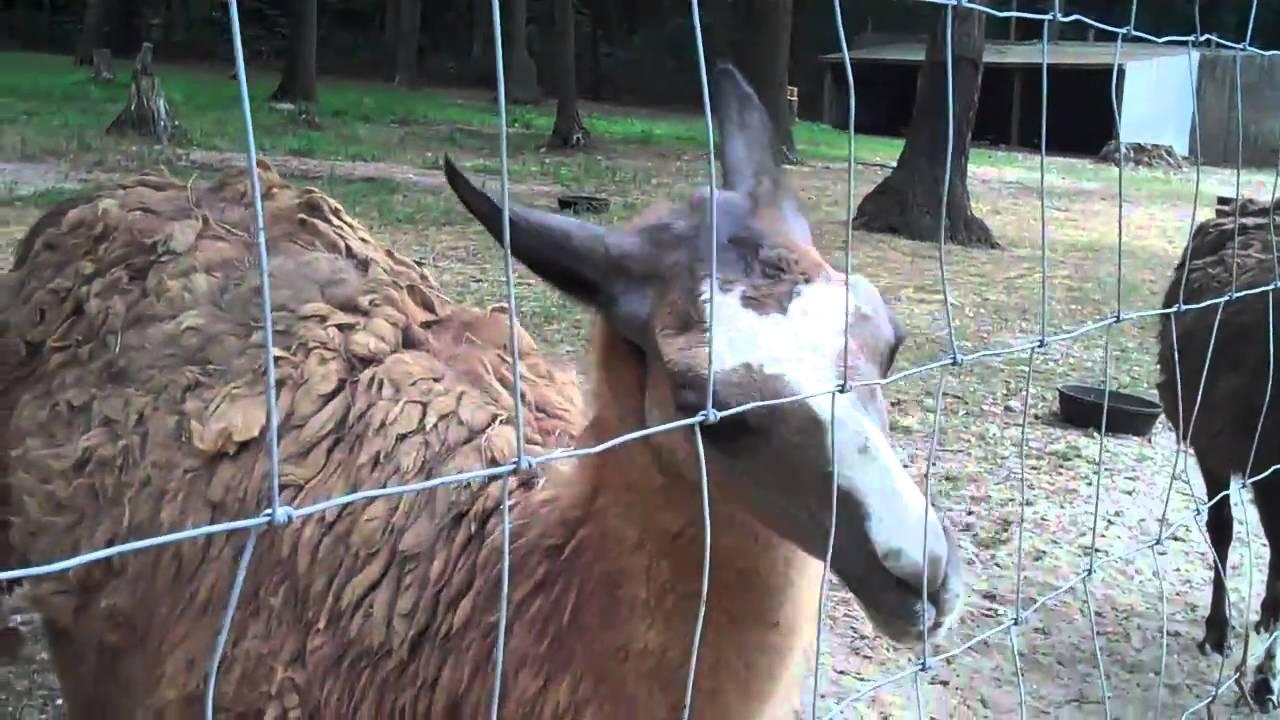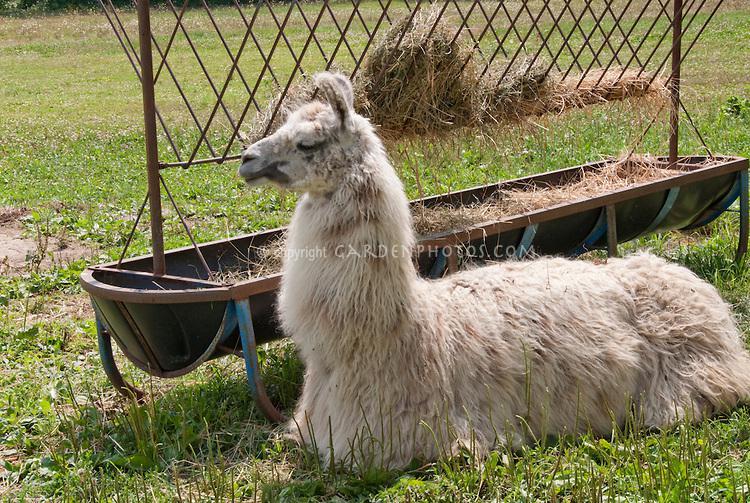The first image is the image on the left, the second image is the image on the right. Assess this claim about the two images: "There is a single llama in one image.". Correct or not? Answer yes or no. Yes. The first image is the image on the left, the second image is the image on the right. Considering the images on both sides, is "An image contains two llamas standing in front of a fence and near at least one white animal that is not a llama." valid? Answer yes or no. No. 